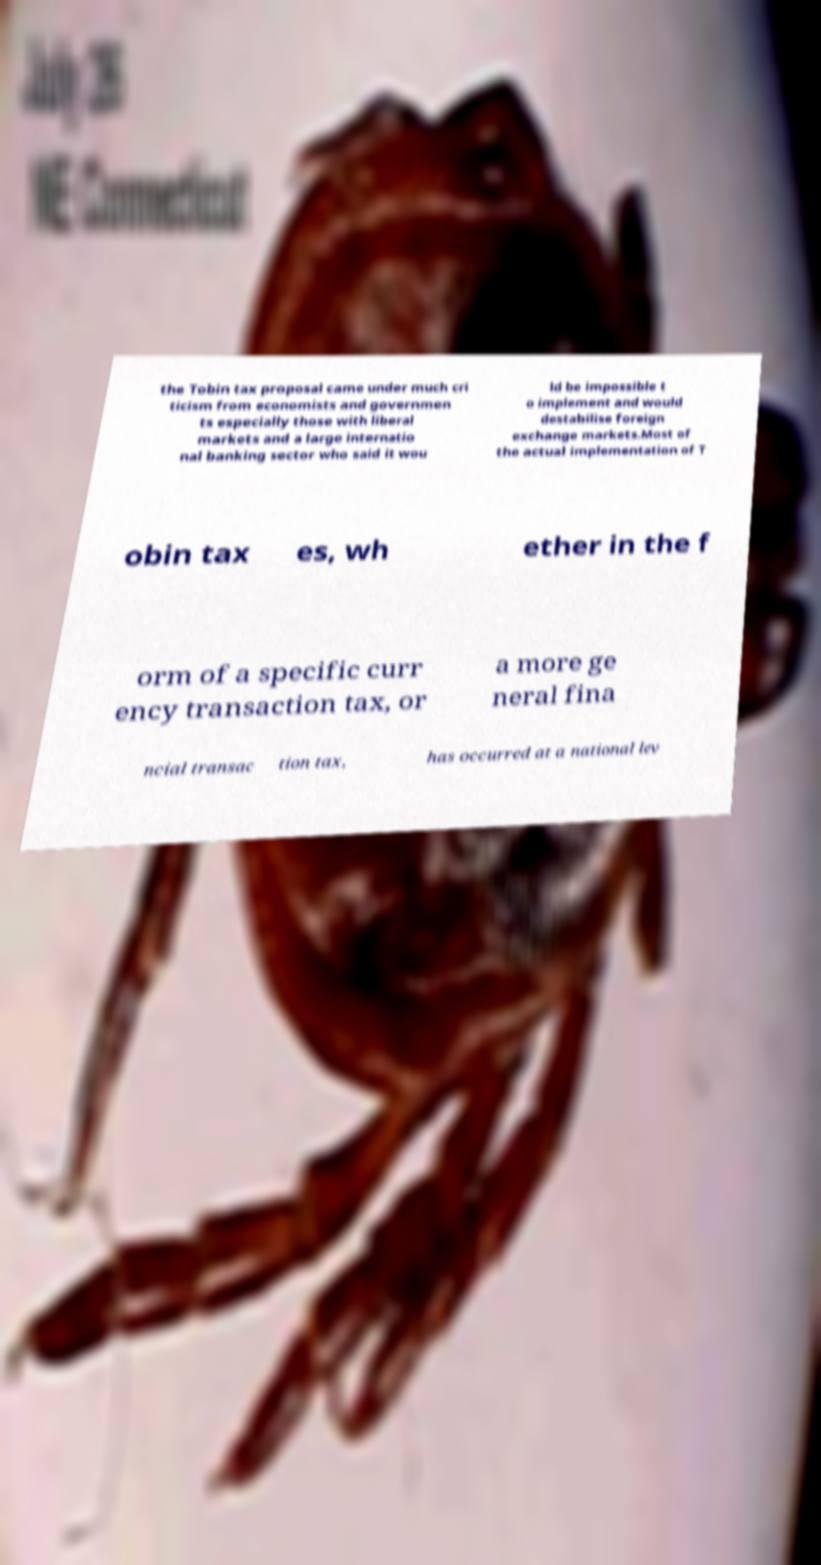What messages or text are displayed in this image? I need them in a readable, typed format. the Tobin tax proposal came under much cri ticism from economists and governmen ts especially those with liberal markets and a large internatio nal banking sector who said it wou ld be impossible t o implement and would destabilise foreign exchange markets.Most of the actual implementation of T obin tax es, wh ether in the f orm of a specific curr ency transaction tax, or a more ge neral fina ncial transac tion tax, has occurred at a national lev 